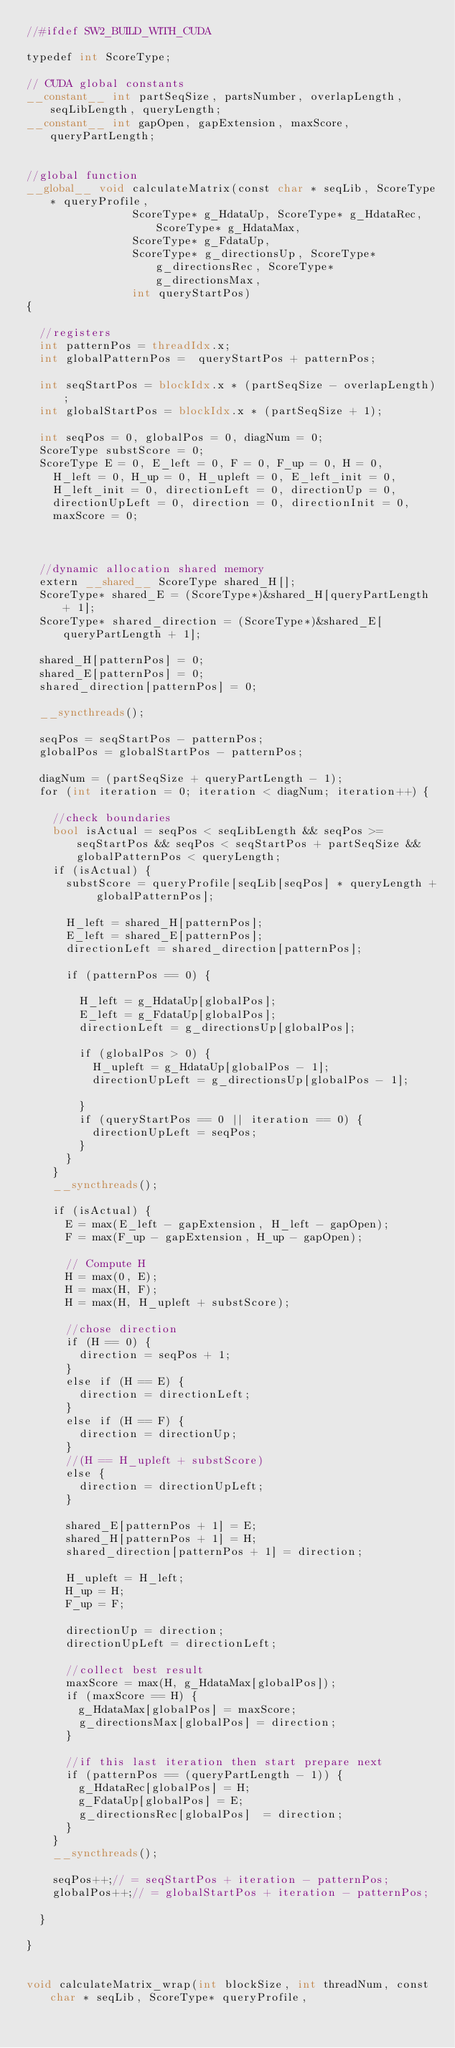<code> <loc_0><loc_0><loc_500><loc_500><_Cuda_>//#ifdef SW2_BUILD_WITH_CUDA

typedef int ScoreType;

// CUDA global constants
__constant__ int partSeqSize, partsNumber, overlapLength, seqLibLength, queryLength;
__constant__ int gapOpen, gapExtension, maxScore, queryPartLength;


//global function
__global__ void calculateMatrix(const char * seqLib, ScoreType* queryProfile,
								ScoreType* g_HdataUp, ScoreType* g_HdataRec, ScoreType* g_HdataMax,
								ScoreType* g_FdataUp,
								ScoreType* g_directionsUp, ScoreType* g_directionsRec, ScoreType* g_directionsMax,
								int queryStartPos) 
{

	//registers
	int patternPos = threadIdx.x;	
	int globalPatternPos =  queryStartPos + patternPos;

	int seqStartPos = blockIdx.x * (partSeqSize - overlapLength);
	int globalStartPos = blockIdx.x * (partSeqSize + 1);
	
	int seqPos = 0, globalPos = 0, diagNum = 0;
	ScoreType substScore = 0;	
	ScoreType E = 0, E_left = 0, F = 0, F_up = 0, H = 0,
		H_left = 0, H_up = 0, H_upleft = 0, E_left_init = 0, 
		H_left_init = 0, directionLeft = 0, directionUp = 0, 
		directionUpLeft = 0, direction = 0, directionInit = 0,
		maxScore = 0;



	//dynamic allocation shared memory
	extern __shared__ ScoreType shared_H[];
	ScoreType* shared_E = (ScoreType*)&shared_H[queryPartLength + 1];
	ScoreType* shared_direction = (ScoreType*)&shared_E[queryPartLength + 1];

	shared_H[patternPos] = 0;
	shared_E[patternPos] = 0;
	shared_direction[patternPos] = 0;

	__syncthreads();	

	seqPos = seqStartPos - patternPos;
	globalPos = globalStartPos - patternPos;

	diagNum = (partSeqSize + queryPartLength - 1);
	for (int iteration = 0; iteration < diagNum; iteration++) {

		//check boundaries
		bool isActual = seqPos < seqLibLength && seqPos >= seqStartPos && seqPos < seqStartPos + partSeqSize && globalPatternPos < queryLength;
		if (isActual) {
			substScore = queryProfile[seqLib[seqPos] * queryLength + globalPatternPos];

			H_left = shared_H[patternPos];
			E_left = shared_E[patternPos];
			directionLeft = shared_direction[patternPos];

			if (patternPos == 0) {

				H_left = g_HdataUp[globalPos];
				E_left = g_FdataUp[globalPos];
				directionLeft = g_directionsUp[globalPos];

				if (globalPos > 0) {
					H_upleft = g_HdataUp[globalPos - 1];
					directionUpLeft = g_directionsUp[globalPos - 1];

				} 
				if (queryStartPos == 0 || iteration == 0) {
					directionUpLeft = seqPos;				
				}	
			}
		}
		__syncthreads();

		if (isActual) {
			E = max(E_left - gapExtension, H_left - gapOpen);
			F = max(F_up - gapExtension, H_up - gapOpen);

			// Compute H
			H = max(0, E);
			H = max(H, F);
			H = max(H, H_upleft + substScore);	

			//chose direction
			if (H == 0) {		 
				direction = seqPos + 1;				
			}
			else if (H == E) {
				direction = directionLeft;
			}	
			else if (H == F) {
				direction = directionUp;
			}	
			//(H == H_upleft + substScore)
			else {
				direction = directionUpLeft;
			}		
				
			shared_E[patternPos + 1] = E;
			shared_H[patternPos + 1] = H;
			shared_direction[patternPos + 1] = direction;

			H_upleft = H_left;
			H_up = H;
			F_up = F;

			directionUp = direction;			
			directionUpLeft = directionLeft;

			//collect best result
			maxScore = max(H, g_HdataMax[globalPos]);
			if (maxScore == H) {
				g_HdataMax[globalPos] = maxScore;
				g_directionsMax[globalPos] = direction;
			}

			//if this last iteration then start prepare next
			if (patternPos == (queryPartLength - 1)) {
				g_HdataRec[globalPos] = H;
				g_FdataUp[globalPos] = E;			
				g_directionsRec[globalPos]  = direction;
			}
		}
		__syncthreads();

		seqPos++;// = seqStartPos + iteration - patternPos;
		globalPos++;// = globalStartPos + iteration - patternPos;

	}

}


void calculateMatrix_wrap(int blockSize, int threadNum, const char * seqLib, ScoreType* queryProfile,                           </code> 